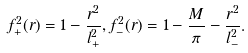Convert formula to latex. <formula><loc_0><loc_0><loc_500><loc_500>f ^ { 2 } _ { + } ( r ) = 1 - \frac { r ^ { 2 } } { l ^ { 2 } _ { + } } , f ^ { 2 } _ { - } ( r ) = 1 - \frac { M } { \pi } - \frac { r ^ { 2 } } { l ^ { 2 } _ { - } } .</formula> 